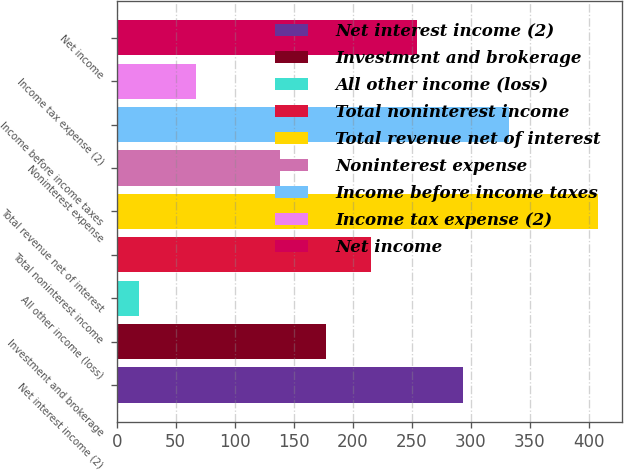Convert chart. <chart><loc_0><loc_0><loc_500><loc_500><bar_chart><fcel>Net interest income (2)<fcel>Investment and brokerage<fcel>All other income (loss)<fcel>Total noninterest income<fcel>Total revenue net of interest<fcel>Noninterest expense<fcel>Income before income taxes<fcel>Income tax expense (2)<fcel>Net income<nl><fcel>293.6<fcel>176.9<fcel>19<fcel>215.8<fcel>408<fcel>138<fcel>332.5<fcel>67<fcel>254.7<nl></chart> 